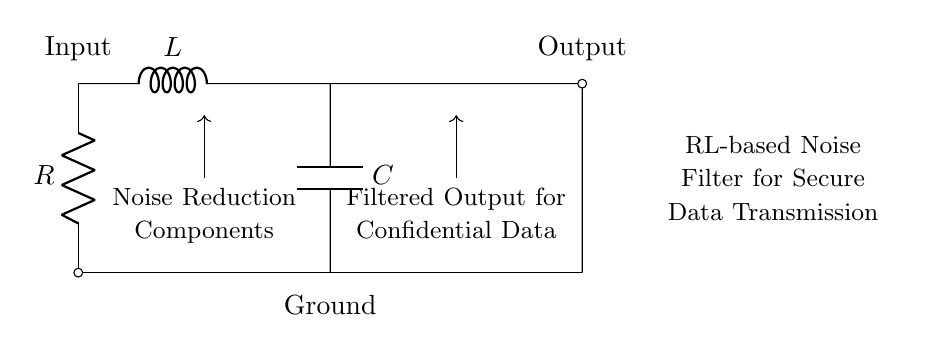What is the input component in this circuit? The input component is the resistor, which is represented as 'R' in the circuit. It is the first component connected to the input of the circuit.
Answer: Resistor What are the three components in the RL-based noise filter? The components include a resistor, an inductor, and a capacitor, as indicated by their respective labels in the diagram.
Answer: Resistor, Inductor, Capacitor What is the purpose of the inductor in this circuit? The inductor is used for filtering out high-frequency noise, helping to clean the signal for confidential data transmission. This is consistent with its role in an RL circuit.
Answer: Noise filtering What is the position of the capacitor in relation to the inductor? The capacitor is connected in parallel to the output after the inductor, which helps in stabilizing the output voltage by smoothing the signal.
Answer: Parallel to output Explain the relationship between input and output in this circuit. The input flows through the resistor and inductor to the capacitor, resulting in a filtered output at the end. This shows that the circuit is designed for effective noise reduction, allowing only the desired signals to pass through.
Answer: Input to output indicates filtered data Identify the role of the capacitor in this circuit. The capacitor acts as a filter to smooth the output signal, reducing voltage fluctuations that may arise during confidential data transmission. This enhances the stability of the circuit.
Answer: Smoothing output 